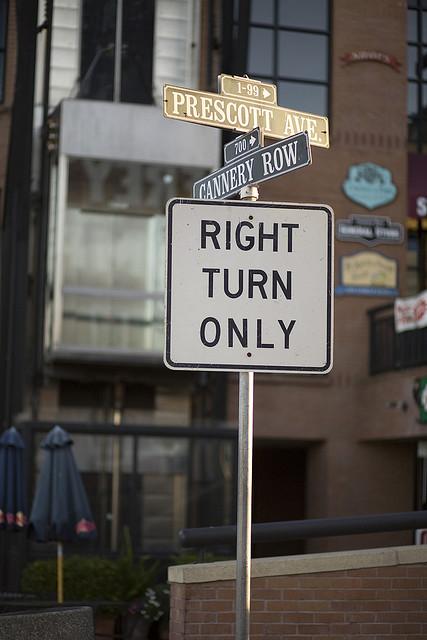What street does this sign say?
Write a very short answer. Right turn only. What street signs are visible?
Short answer required. Right turn only. What color is the board?
Quick response, please. White. Is this what Google Maps says to do?
Quick response, please. Yes. Was this taken in a place of business?
Answer briefly. No. Are the railings plain or ornate?
Keep it brief. Plain. What city is this?
Keep it brief. Prescott. What languages are used on the sign?
Give a very brief answer. English. What is the purpose of the signs?
Be succinct. Traffic. Is the sign next to a tree?
Write a very short answer. No. Where is an orange pipe?
Quick response, please. Nowhere. Is this picture colored?
Concise answer only. Yes. What does this sign mean?
Concise answer only. Right turn only. What Avenue is seen?
Give a very brief answer. Prescott. Which way is the only way a person can turn?
Write a very short answer. Right. Is this a real street sign?
Answer briefly. Yes. 